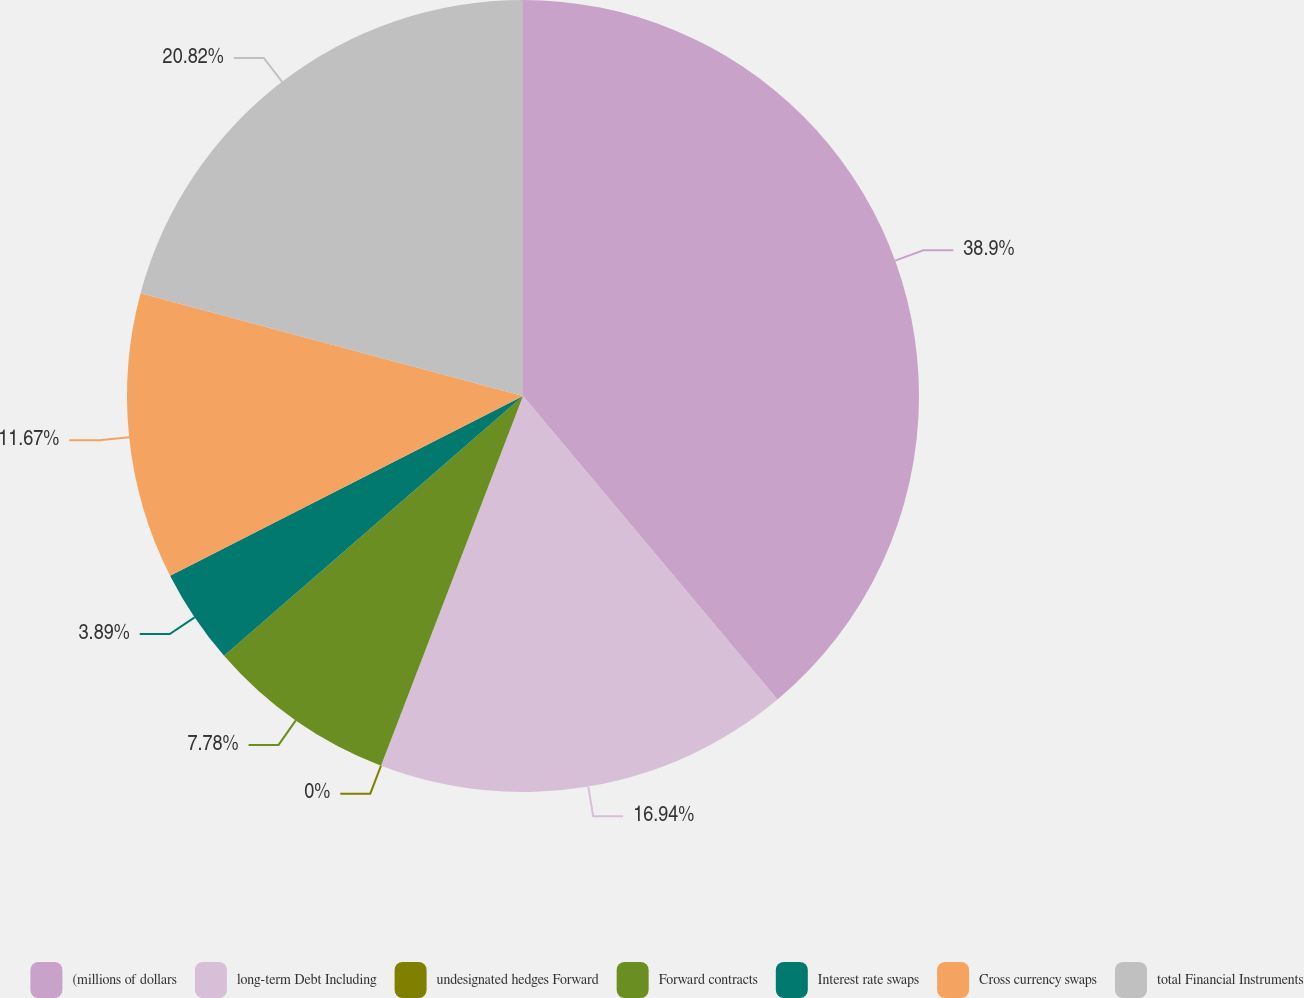Convert chart to OTSL. <chart><loc_0><loc_0><loc_500><loc_500><pie_chart><fcel>(millions of dollars<fcel>long-term Debt Including<fcel>undesignated hedges Forward<fcel>Forward contracts<fcel>Interest rate swaps<fcel>Cross currency swaps<fcel>total Financial Instruments<nl><fcel>38.89%<fcel>16.94%<fcel>0.0%<fcel>7.78%<fcel>3.89%<fcel>11.67%<fcel>20.82%<nl></chart> 